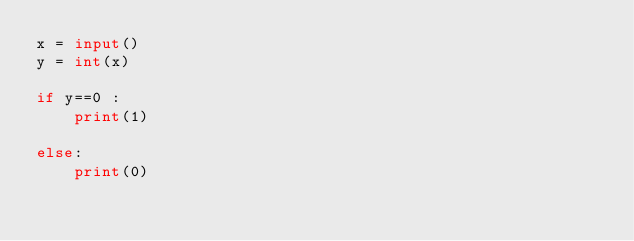<code> <loc_0><loc_0><loc_500><loc_500><_Python_>x = input()
y = int(x)

if y==0 :
    print(1)

else:
    print(0)
    </code> 